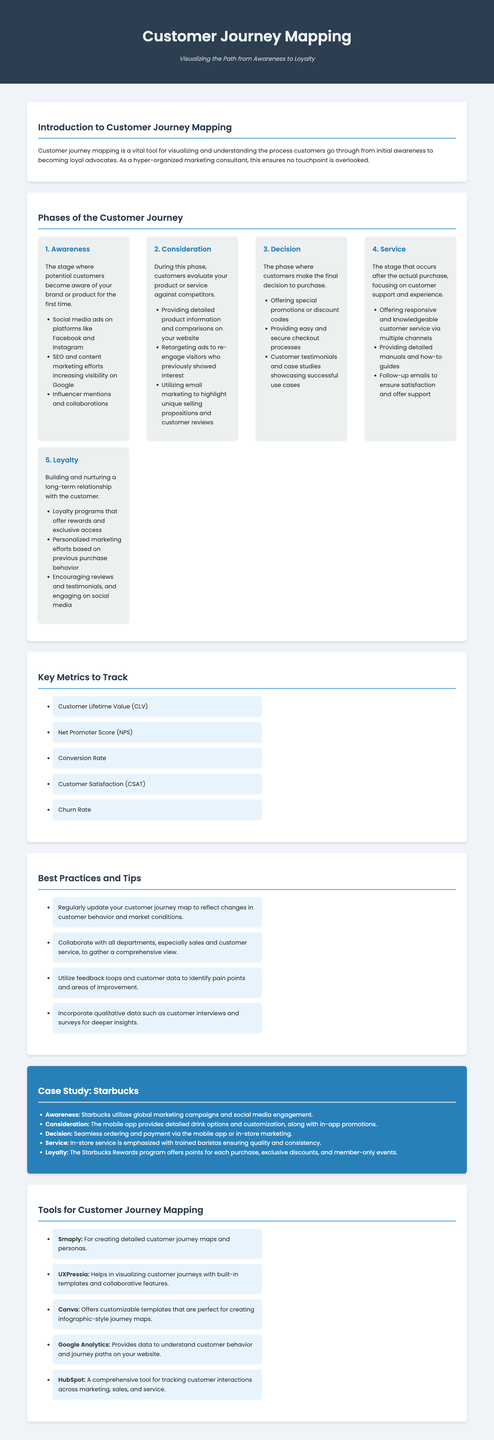What are the five phases of the customer journey? The document outlines the phases as Awareness, Consideration, Decision, Service, and Loyalty.
Answer: Awareness, Consideration, Decision, Service, Loyalty What metric indicates customer satisfaction? The document mentions Customer Satisfaction (CSAT) as a key metric to track.
Answer: Customer Satisfaction (CSAT) What tool helps visualize customer journeys with built-in templates? UXPressia is specified in the document as a tool with these features.
Answer: UXPressia What is the focus of the Service phase? The Service phase centers on customer support and experience after purchase.
Answer: Customer support and experience What loyalty program does Starbucks offer? The document states that Starbucks has the Starbucks Rewards program.
Answer: Starbucks Rewards program What is one best practice for customer journey mapping? Regularly updating the customer journey map is recommended in the document.
Answer: Regularly update your customer journey map What type of marketing strategy is mentioned in the Awareness phase? Influencer mentions and collaborations are highlighted as a strategy in the Awareness phase.
Answer: Influencer mentions and collaborations How many key metrics are listed in the document? There are five key metrics to track mentioned in the document.
Answer: Five What is the main purpose of customer journey mapping? The main purpose is to visualize and understand the process customers go through from awareness to loyalty.
Answer: Visualize and understand the customer process 